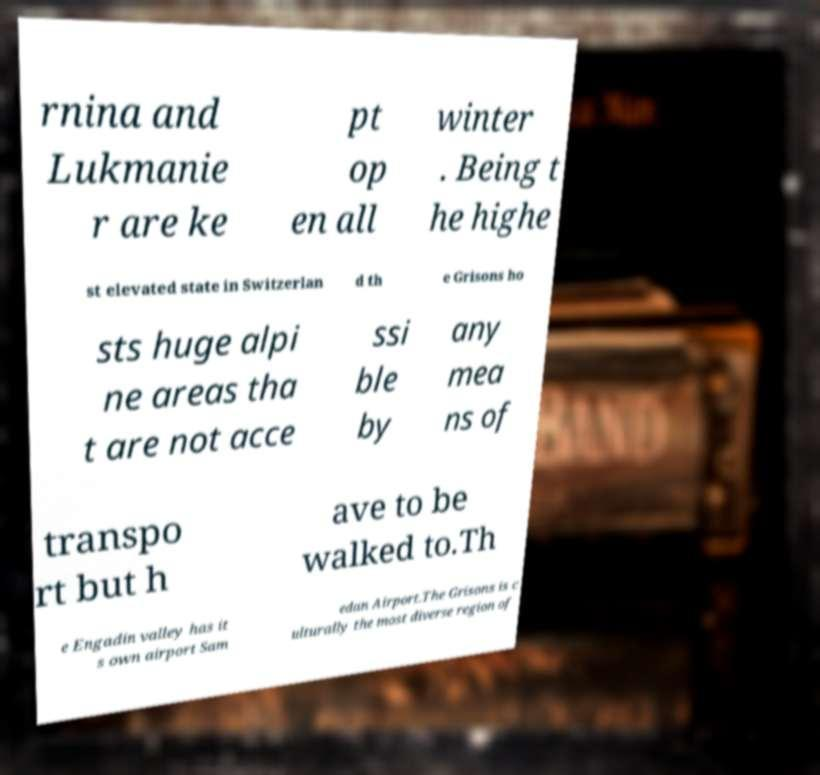I need the written content from this picture converted into text. Can you do that? rnina and Lukmanie r are ke pt op en all winter . Being t he highe st elevated state in Switzerlan d th e Grisons ho sts huge alpi ne areas tha t are not acce ssi ble by any mea ns of transpo rt but h ave to be walked to.Th e Engadin valley has it s own airport Sam edan Airport.The Grisons is c ulturally the most diverse region of 